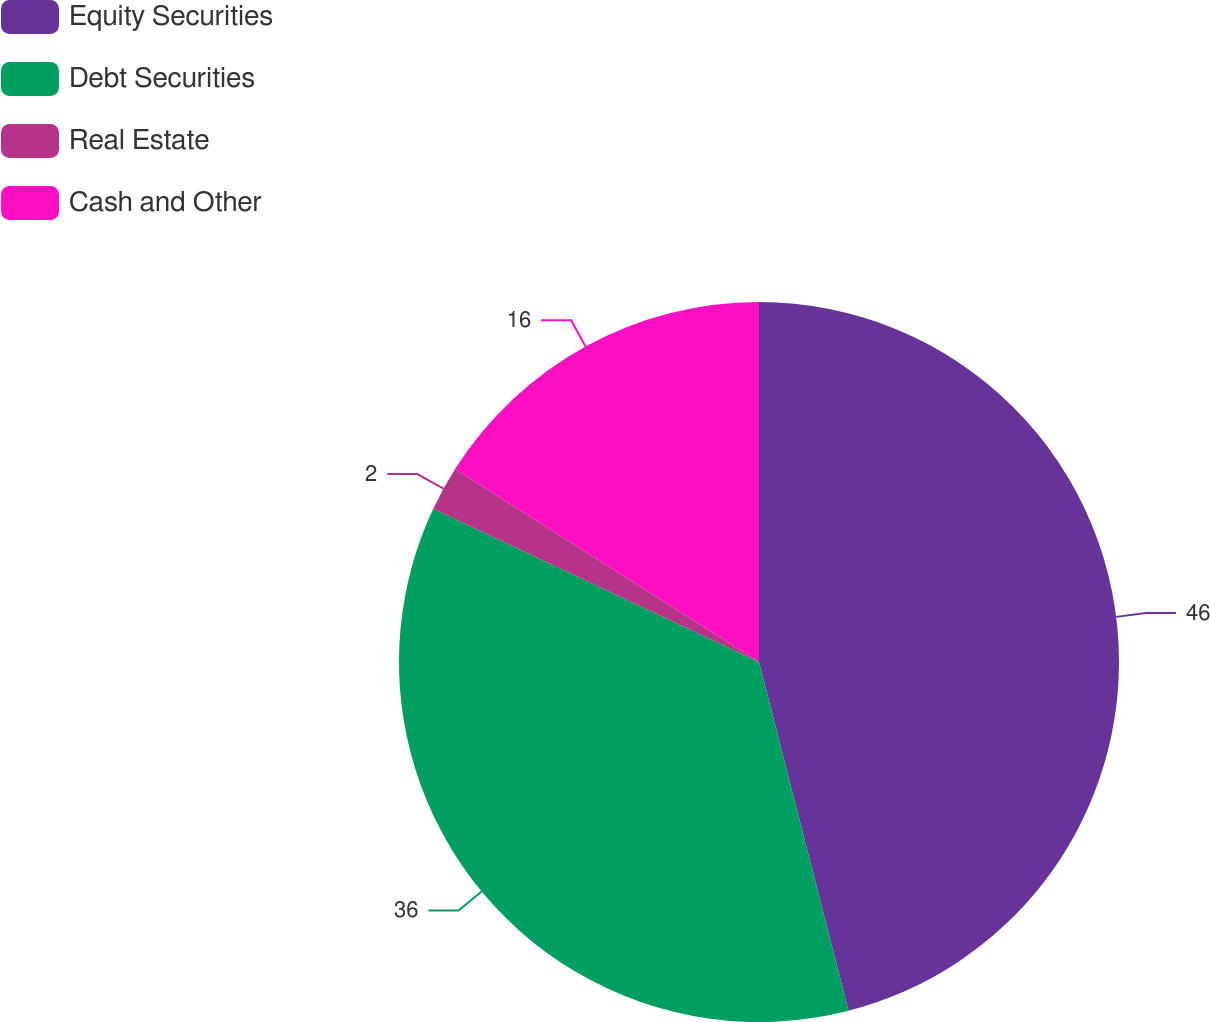<chart> <loc_0><loc_0><loc_500><loc_500><pie_chart><fcel>Equity Securities<fcel>Debt Securities<fcel>Real Estate<fcel>Cash and Other<nl><fcel>46.0%<fcel>36.0%<fcel>2.0%<fcel>16.0%<nl></chart> 